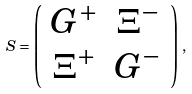Convert formula to latex. <formula><loc_0><loc_0><loc_500><loc_500>S = \left ( \begin{array} { c c } G ^ { + } & \Xi ^ { - } \\ \Xi ^ { + } & G ^ { - } \end{array} \right ) \, ,</formula> 